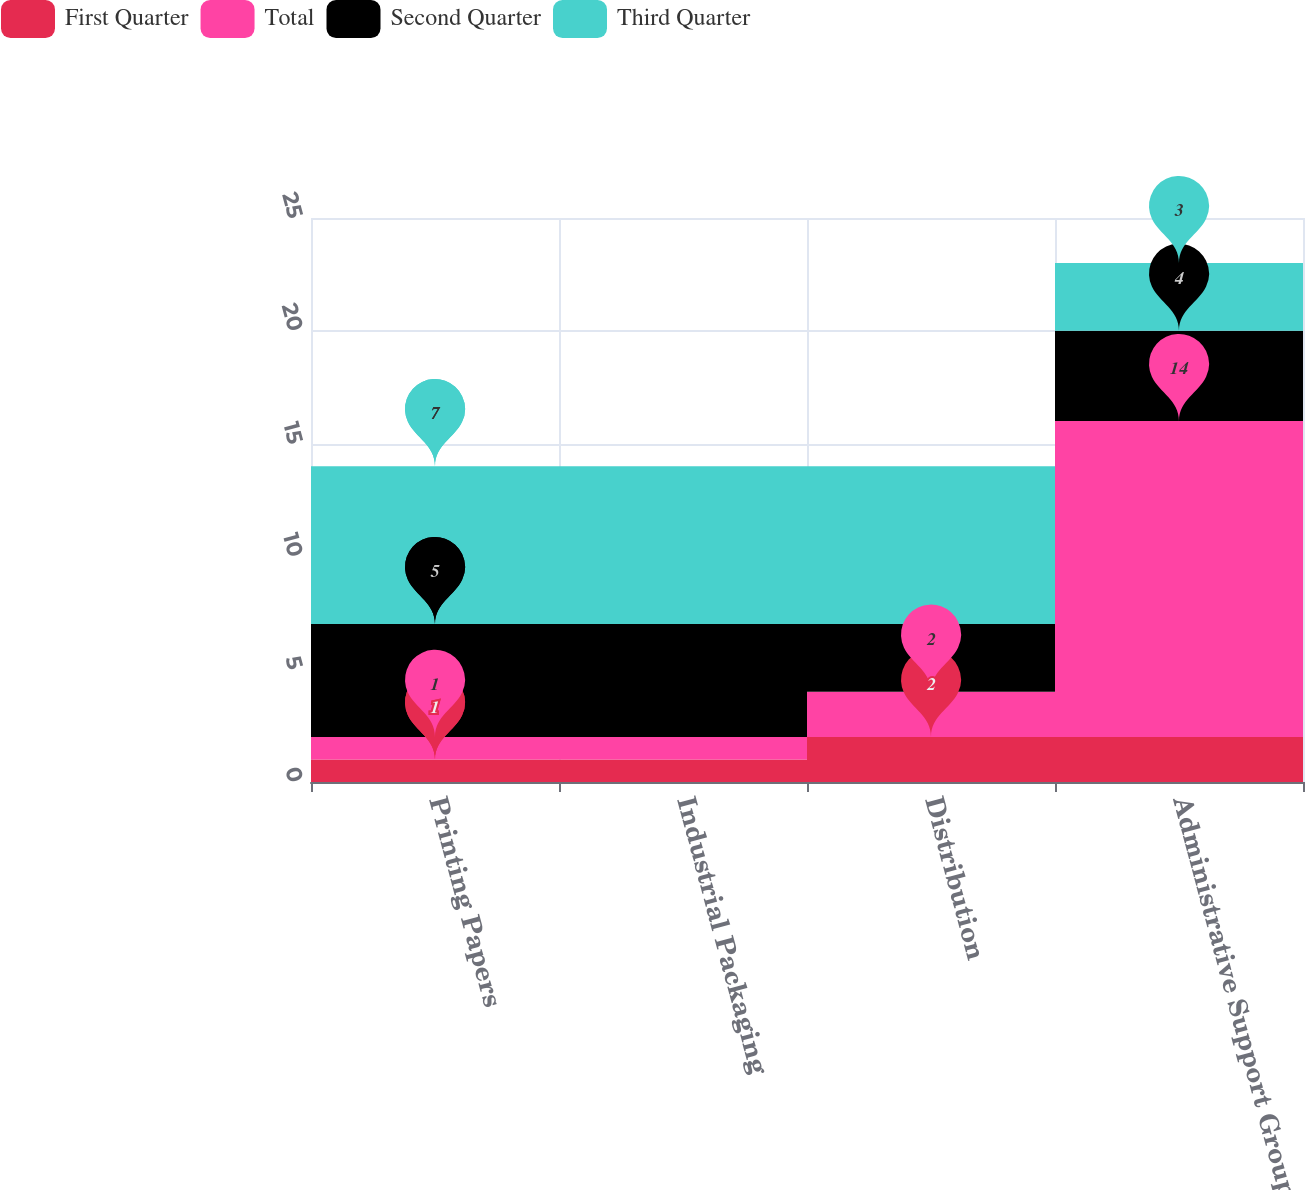Convert chart to OTSL. <chart><loc_0><loc_0><loc_500><loc_500><stacked_bar_chart><ecel><fcel>Printing Papers<fcel>Industrial Packaging<fcel>Distribution<fcel>Administrative Support Groups<nl><fcel>First Quarter<fcel>1<fcel>1<fcel>2<fcel>2<nl><fcel>Total<fcel>1<fcel>1<fcel>2<fcel>14<nl><fcel>Second Quarter<fcel>5<fcel>5<fcel>3<fcel>4<nl><fcel>Third Quarter<fcel>7<fcel>7<fcel>7<fcel>3<nl></chart> 